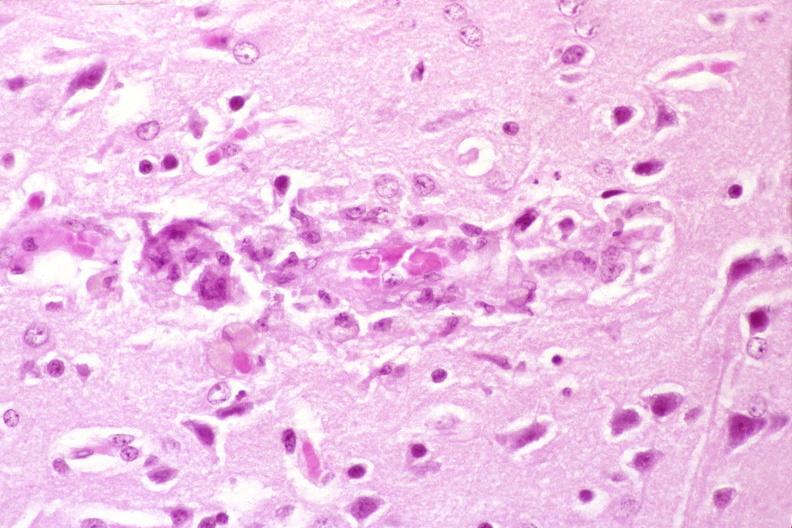what is present?
Answer the question using a single word or phrase. Nervous 